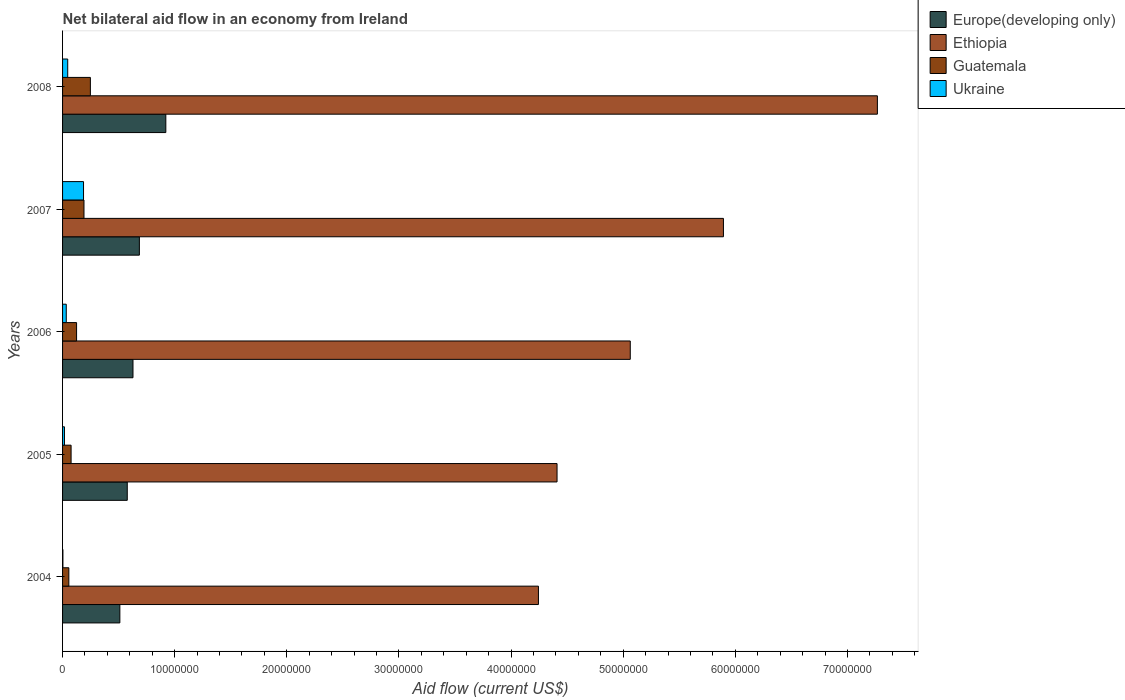How many different coloured bars are there?
Offer a terse response. 4. How many groups of bars are there?
Your answer should be very brief. 5. Are the number of bars per tick equal to the number of legend labels?
Offer a terse response. Yes. How many bars are there on the 4th tick from the bottom?
Keep it short and to the point. 4. What is the label of the 3rd group of bars from the top?
Your answer should be very brief. 2006. What is the net bilateral aid flow in Ukraine in 2007?
Your answer should be compact. 1.87e+06. Across all years, what is the maximum net bilateral aid flow in Guatemala?
Offer a terse response. 2.48e+06. Across all years, what is the minimum net bilateral aid flow in Guatemala?
Make the answer very short. 5.60e+05. In which year was the net bilateral aid flow in Europe(developing only) maximum?
Offer a terse response. 2008. In which year was the net bilateral aid flow in Europe(developing only) minimum?
Offer a very short reply. 2004. What is the total net bilateral aid flow in Ethiopia in the graph?
Ensure brevity in your answer.  2.69e+08. What is the difference between the net bilateral aid flow in Europe(developing only) in 2006 and that in 2007?
Your response must be concise. -5.70e+05. What is the difference between the net bilateral aid flow in Europe(developing only) in 2005 and the net bilateral aid flow in Guatemala in 2007?
Your response must be concise. 3.86e+06. What is the average net bilateral aid flow in Ukraine per year?
Give a very brief answer. 5.72e+05. In the year 2008, what is the difference between the net bilateral aid flow in Guatemala and net bilateral aid flow in Ukraine?
Keep it short and to the point. 2.02e+06. In how many years, is the net bilateral aid flow in Europe(developing only) greater than 72000000 US$?
Give a very brief answer. 0. What is the ratio of the net bilateral aid flow in Ethiopia in 2006 to that in 2008?
Ensure brevity in your answer.  0.7. Is the difference between the net bilateral aid flow in Guatemala in 2004 and 2006 greater than the difference between the net bilateral aid flow in Ukraine in 2004 and 2006?
Provide a succinct answer. No. What is the difference between the highest and the second highest net bilateral aid flow in Europe(developing only)?
Make the answer very short. 2.36e+06. What is the difference between the highest and the lowest net bilateral aid flow in Ukraine?
Keep it short and to the point. 1.84e+06. In how many years, is the net bilateral aid flow in Guatemala greater than the average net bilateral aid flow in Guatemala taken over all years?
Offer a terse response. 2. Is it the case that in every year, the sum of the net bilateral aid flow in Ethiopia and net bilateral aid flow in Europe(developing only) is greater than the sum of net bilateral aid flow in Ukraine and net bilateral aid flow in Guatemala?
Provide a succinct answer. Yes. What does the 2nd bar from the top in 2008 represents?
Offer a terse response. Guatemala. What does the 2nd bar from the bottom in 2008 represents?
Give a very brief answer. Ethiopia. How many bars are there?
Make the answer very short. 20. Are all the bars in the graph horizontal?
Offer a very short reply. Yes. What is the difference between two consecutive major ticks on the X-axis?
Offer a very short reply. 1.00e+07. Does the graph contain any zero values?
Provide a short and direct response. No. Does the graph contain grids?
Offer a terse response. No. How many legend labels are there?
Offer a very short reply. 4. What is the title of the graph?
Offer a terse response. Net bilateral aid flow in an economy from Ireland. Does "Greece" appear as one of the legend labels in the graph?
Your response must be concise. No. What is the Aid flow (current US$) of Europe(developing only) in 2004?
Your response must be concise. 5.11e+06. What is the Aid flow (current US$) in Ethiopia in 2004?
Your answer should be compact. 4.24e+07. What is the Aid flow (current US$) in Guatemala in 2004?
Offer a terse response. 5.60e+05. What is the Aid flow (current US$) of Ukraine in 2004?
Ensure brevity in your answer.  3.00e+04. What is the Aid flow (current US$) of Europe(developing only) in 2005?
Ensure brevity in your answer.  5.77e+06. What is the Aid flow (current US$) of Ethiopia in 2005?
Provide a short and direct response. 4.41e+07. What is the Aid flow (current US$) in Guatemala in 2005?
Keep it short and to the point. 7.60e+05. What is the Aid flow (current US$) of Europe(developing only) in 2006?
Your answer should be compact. 6.28e+06. What is the Aid flow (current US$) in Ethiopia in 2006?
Provide a short and direct response. 5.06e+07. What is the Aid flow (current US$) of Guatemala in 2006?
Keep it short and to the point. 1.25e+06. What is the Aid flow (current US$) of Europe(developing only) in 2007?
Offer a very short reply. 6.85e+06. What is the Aid flow (current US$) in Ethiopia in 2007?
Provide a short and direct response. 5.89e+07. What is the Aid flow (current US$) of Guatemala in 2007?
Provide a succinct answer. 1.91e+06. What is the Aid flow (current US$) of Ukraine in 2007?
Provide a short and direct response. 1.87e+06. What is the Aid flow (current US$) of Europe(developing only) in 2008?
Provide a succinct answer. 9.21e+06. What is the Aid flow (current US$) of Ethiopia in 2008?
Provide a succinct answer. 7.27e+07. What is the Aid flow (current US$) of Guatemala in 2008?
Ensure brevity in your answer.  2.48e+06. What is the Aid flow (current US$) in Ukraine in 2008?
Offer a very short reply. 4.60e+05. Across all years, what is the maximum Aid flow (current US$) in Europe(developing only)?
Ensure brevity in your answer.  9.21e+06. Across all years, what is the maximum Aid flow (current US$) in Ethiopia?
Provide a short and direct response. 7.27e+07. Across all years, what is the maximum Aid flow (current US$) in Guatemala?
Give a very brief answer. 2.48e+06. Across all years, what is the maximum Aid flow (current US$) in Ukraine?
Give a very brief answer. 1.87e+06. Across all years, what is the minimum Aid flow (current US$) in Europe(developing only)?
Provide a succinct answer. 5.11e+06. Across all years, what is the minimum Aid flow (current US$) in Ethiopia?
Your response must be concise. 4.24e+07. Across all years, what is the minimum Aid flow (current US$) of Guatemala?
Keep it short and to the point. 5.60e+05. Across all years, what is the minimum Aid flow (current US$) of Ukraine?
Your response must be concise. 3.00e+04. What is the total Aid flow (current US$) of Europe(developing only) in the graph?
Give a very brief answer. 3.32e+07. What is the total Aid flow (current US$) in Ethiopia in the graph?
Provide a succinct answer. 2.69e+08. What is the total Aid flow (current US$) of Guatemala in the graph?
Keep it short and to the point. 6.96e+06. What is the total Aid flow (current US$) of Ukraine in the graph?
Your response must be concise. 2.86e+06. What is the difference between the Aid flow (current US$) in Europe(developing only) in 2004 and that in 2005?
Provide a succinct answer. -6.60e+05. What is the difference between the Aid flow (current US$) of Ethiopia in 2004 and that in 2005?
Keep it short and to the point. -1.66e+06. What is the difference between the Aid flow (current US$) in Guatemala in 2004 and that in 2005?
Offer a terse response. -2.00e+05. What is the difference between the Aid flow (current US$) of Ukraine in 2004 and that in 2005?
Your answer should be very brief. -1.40e+05. What is the difference between the Aid flow (current US$) of Europe(developing only) in 2004 and that in 2006?
Your answer should be very brief. -1.17e+06. What is the difference between the Aid flow (current US$) of Ethiopia in 2004 and that in 2006?
Give a very brief answer. -8.19e+06. What is the difference between the Aid flow (current US$) in Guatemala in 2004 and that in 2006?
Offer a terse response. -6.90e+05. What is the difference between the Aid flow (current US$) of Ukraine in 2004 and that in 2006?
Provide a succinct answer. -3.00e+05. What is the difference between the Aid flow (current US$) of Europe(developing only) in 2004 and that in 2007?
Make the answer very short. -1.74e+06. What is the difference between the Aid flow (current US$) of Ethiopia in 2004 and that in 2007?
Your answer should be compact. -1.65e+07. What is the difference between the Aid flow (current US$) of Guatemala in 2004 and that in 2007?
Give a very brief answer. -1.35e+06. What is the difference between the Aid flow (current US$) in Ukraine in 2004 and that in 2007?
Provide a succinct answer. -1.84e+06. What is the difference between the Aid flow (current US$) in Europe(developing only) in 2004 and that in 2008?
Your response must be concise. -4.10e+06. What is the difference between the Aid flow (current US$) of Ethiopia in 2004 and that in 2008?
Make the answer very short. -3.02e+07. What is the difference between the Aid flow (current US$) of Guatemala in 2004 and that in 2008?
Give a very brief answer. -1.92e+06. What is the difference between the Aid flow (current US$) of Ukraine in 2004 and that in 2008?
Your answer should be very brief. -4.30e+05. What is the difference between the Aid flow (current US$) of Europe(developing only) in 2005 and that in 2006?
Keep it short and to the point. -5.10e+05. What is the difference between the Aid flow (current US$) of Ethiopia in 2005 and that in 2006?
Your answer should be very brief. -6.53e+06. What is the difference between the Aid flow (current US$) in Guatemala in 2005 and that in 2006?
Your answer should be very brief. -4.90e+05. What is the difference between the Aid flow (current US$) of Europe(developing only) in 2005 and that in 2007?
Offer a terse response. -1.08e+06. What is the difference between the Aid flow (current US$) of Ethiopia in 2005 and that in 2007?
Your answer should be very brief. -1.48e+07. What is the difference between the Aid flow (current US$) of Guatemala in 2005 and that in 2007?
Provide a succinct answer. -1.15e+06. What is the difference between the Aid flow (current US$) in Ukraine in 2005 and that in 2007?
Provide a short and direct response. -1.70e+06. What is the difference between the Aid flow (current US$) in Europe(developing only) in 2005 and that in 2008?
Your response must be concise. -3.44e+06. What is the difference between the Aid flow (current US$) in Ethiopia in 2005 and that in 2008?
Make the answer very short. -2.86e+07. What is the difference between the Aid flow (current US$) in Guatemala in 2005 and that in 2008?
Your response must be concise. -1.72e+06. What is the difference between the Aid flow (current US$) in Ukraine in 2005 and that in 2008?
Give a very brief answer. -2.90e+05. What is the difference between the Aid flow (current US$) of Europe(developing only) in 2006 and that in 2007?
Ensure brevity in your answer.  -5.70e+05. What is the difference between the Aid flow (current US$) in Ethiopia in 2006 and that in 2007?
Your response must be concise. -8.31e+06. What is the difference between the Aid flow (current US$) in Guatemala in 2006 and that in 2007?
Give a very brief answer. -6.60e+05. What is the difference between the Aid flow (current US$) in Ukraine in 2006 and that in 2007?
Give a very brief answer. -1.54e+06. What is the difference between the Aid flow (current US$) of Europe(developing only) in 2006 and that in 2008?
Provide a succinct answer. -2.93e+06. What is the difference between the Aid flow (current US$) of Ethiopia in 2006 and that in 2008?
Your answer should be very brief. -2.20e+07. What is the difference between the Aid flow (current US$) in Guatemala in 2006 and that in 2008?
Offer a very short reply. -1.23e+06. What is the difference between the Aid flow (current US$) in Europe(developing only) in 2007 and that in 2008?
Offer a terse response. -2.36e+06. What is the difference between the Aid flow (current US$) of Ethiopia in 2007 and that in 2008?
Ensure brevity in your answer.  -1.37e+07. What is the difference between the Aid flow (current US$) in Guatemala in 2007 and that in 2008?
Provide a succinct answer. -5.70e+05. What is the difference between the Aid flow (current US$) in Ukraine in 2007 and that in 2008?
Ensure brevity in your answer.  1.41e+06. What is the difference between the Aid flow (current US$) in Europe(developing only) in 2004 and the Aid flow (current US$) in Ethiopia in 2005?
Make the answer very short. -3.90e+07. What is the difference between the Aid flow (current US$) of Europe(developing only) in 2004 and the Aid flow (current US$) of Guatemala in 2005?
Your response must be concise. 4.35e+06. What is the difference between the Aid flow (current US$) of Europe(developing only) in 2004 and the Aid flow (current US$) of Ukraine in 2005?
Ensure brevity in your answer.  4.94e+06. What is the difference between the Aid flow (current US$) in Ethiopia in 2004 and the Aid flow (current US$) in Guatemala in 2005?
Provide a succinct answer. 4.17e+07. What is the difference between the Aid flow (current US$) in Ethiopia in 2004 and the Aid flow (current US$) in Ukraine in 2005?
Your response must be concise. 4.23e+07. What is the difference between the Aid flow (current US$) in Europe(developing only) in 2004 and the Aid flow (current US$) in Ethiopia in 2006?
Ensure brevity in your answer.  -4.55e+07. What is the difference between the Aid flow (current US$) of Europe(developing only) in 2004 and the Aid flow (current US$) of Guatemala in 2006?
Your answer should be very brief. 3.86e+06. What is the difference between the Aid flow (current US$) of Europe(developing only) in 2004 and the Aid flow (current US$) of Ukraine in 2006?
Provide a succinct answer. 4.78e+06. What is the difference between the Aid flow (current US$) in Ethiopia in 2004 and the Aid flow (current US$) in Guatemala in 2006?
Your answer should be compact. 4.12e+07. What is the difference between the Aid flow (current US$) in Ethiopia in 2004 and the Aid flow (current US$) in Ukraine in 2006?
Provide a succinct answer. 4.21e+07. What is the difference between the Aid flow (current US$) of Guatemala in 2004 and the Aid flow (current US$) of Ukraine in 2006?
Make the answer very short. 2.30e+05. What is the difference between the Aid flow (current US$) of Europe(developing only) in 2004 and the Aid flow (current US$) of Ethiopia in 2007?
Your response must be concise. -5.38e+07. What is the difference between the Aid flow (current US$) of Europe(developing only) in 2004 and the Aid flow (current US$) of Guatemala in 2007?
Keep it short and to the point. 3.20e+06. What is the difference between the Aid flow (current US$) of Europe(developing only) in 2004 and the Aid flow (current US$) of Ukraine in 2007?
Make the answer very short. 3.24e+06. What is the difference between the Aid flow (current US$) in Ethiopia in 2004 and the Aid flow (current US$) in Guatemala in 2007?
Give a very brief answer. 4.05e+07. What is the difference between the Aid flow (current US$) of Ethiopia in 2004 and the Aid flow (current US$) of Ukraine in 2007?
Provide a short and direct response. 4.06e+07. What is the difference between the Aid flow (current US$) in Guatemala in 2004 and the Aid flow (current US$) in Ukraine in 2007?
Your answer should be compact. -1.31e+06. What is the difference between the Aid flow (current US$) in Europe(developing only) in 2004 and the Aid flow (current US$) in Ethiopia in 2008?
Provide a short and direct response. -6.76e+07. What is the difference between the Aid flow (current US$) in Europe(developing only) in 2004 and the Aid flow (current US$) in Guatemala in 2008?
Keep it short and to the point. 2.63e+06. What is the difference between the Aid flow (current US$) in Europe(developing only) in 2004 and the Aid flow (current US$) in Ukraine in 2008?
Your answer should be very brief. 4.65e+06. What is the difference between the Aid flow (current US$) in Ethiopia in 2004 and the Aid flow (current US$) in Guatemala in 2008?
Make the answer very short. 4.00e+07. What is the difference between the Aid flow (current US$) of Ethiopia in 2004 and the Aid flow (current US$) of Ukraine in 2008?
Provide a short and direct response. 4.20e+07. What is the difference between the Aid flow (current US$) of Europe(developing only) in 2005 and the Aid flow (current US$) of Ethiopia in 2006?
Provide a succinct answer. -4.49e+07. What is the difference between the Aid flow (current US$) in Europe(developing only) in 2005 and the Aid flow (current US$) in Guatemala in 2006?
Give a very brief answer. 4.52e+06. What is the difference between the Aid flow (current US$) of Europe(developing only) in 2005 and the Aid flow (current US$) of Ukraine in 2006?
Make the answer very short. 5.44e+06. What is the difference between the Aid flow (current US$) of Ethiopia in 2005 and the Aid flow (current US$) of Guatemala in 2006?
Offer a very short reply. 4.28e+07. What is the difference between the Aid flow (current US$) in Ethiopia in 2005 and the Aid flow (current US$) in Ukraine in 2006?
Offer a terse response. 4.38e+07. What is the difference between the Aid flow (current US$) in Europe(developing only) in 2005 and the Aid flow (current US$) in Ethiopia in 2007?
Offer a very short reply. -5.32e+07. What is the difference between the Aid flow (current US$) of Europe(developing only) in 2005 and the Aid flow (current US$) of Guatemala in 2007?
Provide a short and direct response. 3.86e+06. What is the difference between the Aid flow (current US$) of Europe(developing only) in 2005 and the Aid flow (current US$) of Ukraine in 2007?
Offer a terse response. 3.90e+06. What is the difference between the Aid flow (current US$) in Ethiopia in 2005 and the Aid flow (current US$) in Guatemala in 2007?
Keep it short and to the point. 4.22e+07. What is the difference between the Aid flow (current US$) in Ethiopia in 2005 and the Aid flow (current US$) in Ukraine in 2007?
Keep it short and to the point. 4.22e+07. What is the difference between the Aid flow (current US$) of Guatemala in 2005 and the Aid flow (current US$) of Ukraine in 2007?
Your answer should be very brief. -1.11e+06. What is the difference between the Aid flow (current US$) in Europe(developing only) in 2005 and the Aid flow (current US$) in Ethiopia in 2008?
Provide a succinct answer. -6.69e+07. What is the difference between the Aid flow (current US$) of Europe(developing only) in 2005 and the Aid flow (current US$) of Guatemala in 2008?
Offer a very short reply. 3.29e+06. What is the difference between the Aid flow (current US$) in Europe(developing only) in 2005 and the Aid flow (current US$) in Ukraine in 2008?
Your answer should be compact. 5.31e+06. What is the difference between the Aid flow (current US$) in Ethiopia in 2005 and the Aid flow (current US$) in Guatemala in 2008?
Offer a terse response. 4.16e+07. What is the difference between the Aid flow (current US$) of Ethiopia in 2005 and the Aid flow (current US$) of Ukraine in 2008?
Offer a very short reply. 4.36e+07. What is the difference between the Aid flow (current US$) in Guatemala in 2005 and the Aid flow (current US$) in Ukraine in 2008?
Ensure brevity in your answer.  3.00e+05. What is the difference between the Aid flow (current US$) of Europe(developing only) in 2006 and the Aid flow (current US$) of Ethiopia in 2007?
Offer a very short reply. -5.27e+07. What is the difference between the Aid flow (current US$) in Europe(developing only) in 2006 and the Aid flow (current US$) in Guatemala in 2007?
Ensure brevity in your answer.  4.37e+06. What is the difference between the Aid flow (current US$) of Europe(developing only) in 2006 and the Aid flow (current US$) of Ukraine in 2007?
Provide a succinct answer. 4.41e+06. What is the difference between the Aid flow (current US$) in Ethiopia in 2006 and the Aid flow (current US$) in Guatemala in 2007?
Give a very brief answer. 4.87e+07. What is the difference between the Aid flow (current US$) in Ethiopia in 2006 and the Aid flow (current US$) in Ukraine in 2007?
Your answer should be very brief. 4.88e+07. What is the difference between the Aid flow (current US$) in Guatemala in 2006 and the Aid flow (current US$) in Ukraine in 2007?
Make the answer very short. -6.20e+05. What is the difference between the Aid flow (current US$) in Europe(developing only) in 2006 and the Aid flow (current US$) in Ethiopia in 2008?
Your response must be concise. -6.64e+07. What is the difference between the Aid flow (current US$) in Europe(developing only) in 2006 and the Aid flow (current US$) in Guatemala in 2008?
Your answer should be compact. 3.80e+06. What is the difference between the Aid flow (current US$) in Europe(developing only) in 2006 and the Aid flow (current US$) in Ukraine in 2008?
Keep it short and to the point. 5.82e+06. What is the difference between the Aid flow (current US$) in Ethiopia in 2006 and the Aid flow (current US$) in Guatemala in 2008?
Offer a very short reply. 4.82e+07. What is the difference between the Aid flow (current US$) in Ethiopia in 2006 and the Aid flow (current US$) in Ukraine in 2008?
Provide a succinct answer. 5.02e+07. What is the difference between the Aid flow (current US$) of Guatemala in 2006 and the Aid flow (current US$) of Ukraine in 2008?
Provide a short and direct response. 7.90e+05. What is the difference between the Aid flow (current US$) of Europe(developing only) in 2007 and the Aid flow (current US$) of Ethiopia in 2008?
Provide a succinct answer. -6.58e+07. What is the difference between the Aid flow (current US$) of Europe(developing only) in 2007 and the Aid flow (current US$) of Guatemala in 2008?
Offer a very short reply. 4.37e+06. What is the difference between the Aid flow (current US$) of Europe(developing only) in 2007 and the Aid flow (current US$) of Ukraine in 2008?
Provide a short and direct response. 6.39e+06. What is the difference between the Aid flow (current US$) of Ethiopia in 2007 and the Aid flow (current US$) of Guatemala in 2008?
Provide a short and direct response. 5.65e+07. What is the difference between the Aid flow (current US$) of Ethiopia in 2007 and the Aid flow (current US$) of Ukraine in 2008?
Provide a succinct answer. 5.85e+07. What is the difference between the Aid flow (current US$) in Guatemala in 2007 and the Aid flow (current US$) in Ukraine in 2008?
Offer a terse response. 1.45e+06. What is the average Aid flow (current US$) of Europe(developing only) per year?
Your answer should be very brief. 6.64e+06. What is the average Aid flow (current US$) of Ethiopia per year?
Offer a very short reply. 5.38e+07. What is the average Aid flow (current US$) of Guatemala per year?
Offer a terse response. 1.39e+06. What is the average Aid flow (current US$) of Ukraine per year?
Offer a very short reply. 5.72e+05. In the year 2004, what is the difference between the Aid flow (current US$) of Europe(developing only) and Aid flow (current US$) of Ethiopia?
Your response must be concise. -3.73e+07. In the year 2004, what is the difference between the Aid flow (current US$) of Europe(developing only) and Aid flow (current US$) of Guatemala?
Give a very brief answer. 4.55e+06. In the year 2004, what is the difference between the Aid flow (current US$) of Europe(developing only) and Aid flow (current US$) of Ukraine?
Your response must be concise. 5.08e+06. In the year 2004, what is the difference between the Aid flow (current US$) in Ethiopia and Aid flow (current US$) in Guatemala?
Your answer should be very brief. 4.19e+07. In the year 2004, what is the difference between the Aid flow (current US$) in Ethiopia and Aid flow (current US$) in Ukraine?
Give a very brief answer. 4.24e+07. In the year 2004, what is the difference between the Aid flow (current US$) in Guatemala and Aid flow (current US$) in Ukraine?
Provide a succinct answer. 5.30e+05. In the year 2005, what is the difference between the Aid flow (current US$) in Europe(developing only) and Aid flow (current US$) in Ethiopia?
Keep it short and to the point. -3.83e+07. In the year 2005, what is the difference between the Aid flow (current US$) in Europe(developing only) and Aid flow (current US$) in Guatemala?
Give a very brief answer. 5.01e+06. In the year 2005, what is the difference between the Aid flow (current US$) in Europe(developing only) and Aid flow (current US$) in Ukraine?
Your answer should be compact. 5.60e+06. In the year 2005, what is the difference between the Aid flow (current US$) in Ethiopia and Aid flow (current US$) in Guatemala?
Ensure brevity in your answer.  4.33e+07. In the year 2005, what is the difference between the Aid flow (current US$) in Ethiopia and Aid flow (current US$) in Ukraine?
Give a very brief answer. 4.39e+07. In the year 2005, what is the difference between the Aid flow (current US$) of Guatemala and Aid flow (current US$) of Ukraine?
Your response must be concise. 5.90e+05. In the year 2006, what is the difference between the Aid flow (current US$) of Europe(developing only) and Aid flow (current US$) of Ethiopia?
Provide a succinct answer. -4.44e+07. In the year 2006, what is the difference between the Aid flow (current US$) in Europe(developing only) and Aid flow (current US$) in Guatemala?
Keep it short and to the point. 5.03e+06. In the year 2006, what is the difference between the Aid flow (current US$) of Europe(developing only) and Aid flow (current US$) of Ukraine?
Your answer should be very brief. 5.95e+06. In the year 2006, what is the difference between the Aid flow (current US$) in Ethiopia and Aid flow (current US$) in Guatemala?
Your answer should be very brief. 4.94e+07. In the year 2006, what is the difference between the Aid flow (current US$) of Ethiopia and Aid flow (current US$) of Ukraine?
Offer a terse response. 5.03e+07. In the year 2006, what is the difference between the Aid flow (current US$) of Guatemala and Aid flow (current US$) of Ukraine?
Your answer should be very brief. 9.20e+05. In the year 2007, what is the difference between the Aid flow (current US$) in Europe(developing only) and Aid flow (current US$) in Ethiopia?
Provide a succinct answer. -5.21e+07. In the year 2007, what is the difference between the Aid flow (current US$) of Europe(developing only) and Aid flow (current US$) of Guatemala?
Your response must be concise. 4.94e+06. In the year 2007, what is the difference between the Aid flow (current US$) in Europe(developing only) and Aid flow (current US$) in Ukraine?
Keep it short and to the point. 4.98e+06. In the year 2007, what is the difference between the Aid flow (current US$) in Ethiopia and Aid flow (current US$) in Guatemala?
Your answer should be very brief. 5.70e+07. In the year 2007, what is the difference between the Aid flow (current US$) of Ethiopia and Aid flow (current US$) of Ukraine?
Provide a short and direct response. 5.71e+07. In the year 2008, what is the difference between the Aid flow (current US$) of Europe(developing only) and Aid flow (current US$) of Ethiopia?
Offer a terse response. -6.35e+07. In the year 2008, what is the difference between the Aid flow (current US$) in Europe(developing only) and Aid flow (current US$) in Guatemala?
Provide a short and direct response. 6.73e+06. In the year 2008, what is the difference between the Aid flow (current US$) in Europe(developing only) and Aid flow (current US$) in Ukraine?
Provide a succinct answer. 8.75e+06. In the year 2008, what is the difference between the Aid flow (current US$) in Ethiopia and Aid flow (current US$) in Guatemala?
Make the answer very short. 7.02e+07. In the year 2008, what is the difference between the Aid flow (current US$) in Ethiopia and Aid flow (current US$) in Ukraine?
Offer a very short reply. 7.22e+07. In the year 2008, what is the difference between the Aid flow (current US$) in Guatemala and Aid flow (current US$) in Ukraine?
Give a very brief answer. 2.02e+06. What is the ratio of the Aid flow (current US$) of Europe(developing only) in 2004 to that in 2005?
Your response must be concise. 0.89. What is the ratio of the Aid flow (current US$) in Ethiopia in 2004 to that in 2005?
Ensure brevity in your answer.  0.96. What is the ratio of the Aid flow (current US$) of Guatemala in 2004 to that in 2005?
Your response must be concise. 0.74. What is the ratio of the Aid flow (current US$) in Ukraine in 2004 to that in 2005?
Your answer should be very brief. 0.18. What is the ratio of the Aid flow (current US$) in Europe(developing only) in 2004 to that in 2006?
Your response must be concise. 0.81. What is the ratio of the Aid flow (current US$) in Ethiopia in 2004 to that in 2006?
Ensure brevity in your answer.  0.84. What is the ratio of the Aid flow (current US$) in Guatemala in 2004 to that in 2006?
Keep it short and to the point. 0.45. What is the ratio of the Aid flow (current US$) in Ukraine in 2004 to that in 2006?
Your response must be concise. 0.09. What is the ratio of the Aid flow (current US$) in Europe(developing only) in 2004 to that in 2007?
Keep it short and to the point. 0.75. What is the ratio of the Aid flow (current US$) of Ethiopia in 2004 to that in 2007?
Offer a terse response. 0.72. What is the ratio of the Aid flow (current US$) in Guatemala in 2004 to that in 2007?
Your answer should be compact. 0.29. What is the ratio of the Aid flow (current US$) of Ukraine in 2004 to that in 2007?
Offer a very short reply. 0.02. What is the ratio of the Aid flow (current US$) in Europe(developing only) in 2004 to that in 2008?
Keep it short and to the point. 0.55. What is the ratio of the Aid flow (current US$) of Ethiopia in 2004 to that in 2008?
Your answer should be compact. 0.58. What is the ratio of the Aid flow (current US$) of Guatemala in 2004 to that in 2008?
Keep it short and to the point. 0.23. What is the ratio of the Aid flow (current US$) in Ukraine in 2004 to that in 2008?
Keep it short and to the point. 0.07. What is the ratio of the Aid flow (current US$) of Europe(developing only) in 2005 to that in 2006?
Keep it short and to the point. 0.92. What is the ratio of the Aid flow (current US$) of Ethiopia in 2005 to that in 2006?
Keep it short and to the point. 0.87. What is the ratio of the Aid flow (current US$) of Guatemala in 2005 to that in 2006?
Make the answer very short. 0.61. What is the ratio of the Aid flow (current US$) in Ukraine in 2005 to that in 2006?
Make the answer very short. 0.52. What is the ratio of the Aid flow (current US$) in Europe(developing only) in 2005 to that in 2007?
Keep it short and to the point. 0.84. What is the ratio of the Aid flow (current US$) of Ethiopia in 2005 to that in 2007?
Provide a short and direct response. 0.75. What is the ratio of the Aid flow (current US$) of Guatemala in 2005 to that in 2007?
Provide a short and direct response. 0.4. What is the ratio of the Aid flow (current US$) in Ukraine in 2005 to that in 2007?
Your answer should be compact. 0.09. What is the ratio of the Aid flow (current US$) of Europe(developing only) in 2005 to that in 2008?
Offer a terse response. 0.63. What is the ratio of the Aid flow (current US$) in Ethiopia in 2005 to that in 2008?
Make the answer very short. 0.61. What is the ratio of the Aid flow (current US$) of Guatemala in 2005 to that in 2008?
Your answer should be very brief. 0.31. What is the ratio of the Aid flow (current US$) of Ukraine in 2005 to that in 2008?
Make the answer very short. 0.37. What is the ratio of the Aid flow (current US$) in Europe(developing only) in 2006 to that in 2007?
Provide a short and direct response. 0.92. What is the ratio of the Aid flow (current US$) of Ethiopia in 2006 to that in 2007?
Your response must be concise. 0.86. What is the ratio of the Aid flow (current US$) of Guatemala in 2006 to that in 2007?
Give a very brief answer. 0.65. What is the ratio of the Aid flow (current US$) of Ukraine in 2006 to that in 2007?
Your answer should be very brief. 0.18. What is the ratio of the Aid flow (current US$) of Europe(developing only) in 2006 to that in 2008?
Give a very brief answer. 0.68. What is the ratio of the Aid flow (current US$) in Ethiopia in 2006 to that in 2008?
Your response must be concise. 0.7. What is the ratio of the Aid flow (current US$) in Guatemala in 2006 to that in 2008?
Give a very brief answer. 0.5. What is the ratio of the Aid flow (current US$) of Ukraine in 2006 to that in 2008?
Make the answer very short. 0.72. What is the ratio of the Aid flow (current US$) in Europe(developing only) in 2007 to that in 2008?
Make the answer very short. 0.74. What is the ratio of the Aid flow (current US$) in Ethiopia in 2007 to that in 2008?
Offer a very short reply. 0.81. What is the ratio of the Aid flow (current US$) in Guatemala in 2007 to that in 2008?
Your answer should be compact. 0.77. What is the ratio of the Aid flow (current US$) in Ukraine in 2007 to that in 2008?
Provide a short and direct response. 4.07. What is the difference between the highest and the second highest Aid flow (current US$) of Europe(developing only)?
Offer a terse response. 2.36e+06. What is the difference between the highest and the second highest Aid flow (current US$) in Ethiopia?
Provide a short and direct response. 1.37e+07. What is the difference between the highest and the second highest Aid flow (current US$) of Guatemala?
Offer a terse response. 5.70e+05. What is the difference between the highest and the second highest Aid flow (current US$) of Ukraine?
Offer a terse response. 1.41e+06. What is the difference between the highest and the lowest Aid flow (current US$) in Europe(developing only)?
Provide a succinct answer. 4.10e+06. What is the difference between the highest and the lowest Aid flow (current US$) of Ethiopia?
Ensure brevity in your answer.  3.02e+07. What is the difference between the highest and the lowest Aid flow (current US$) of Guatemala?
Provide a short and direct response. 1.92e+06. What is the difference between the highest and the lowest Aid flow (current US$) in Ukraine?
Provide a short and direct response. 1.84e+06. 